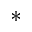<formula> <loc_0><loc_0><loc_500><loc_500>^ { \ast }</formula> 